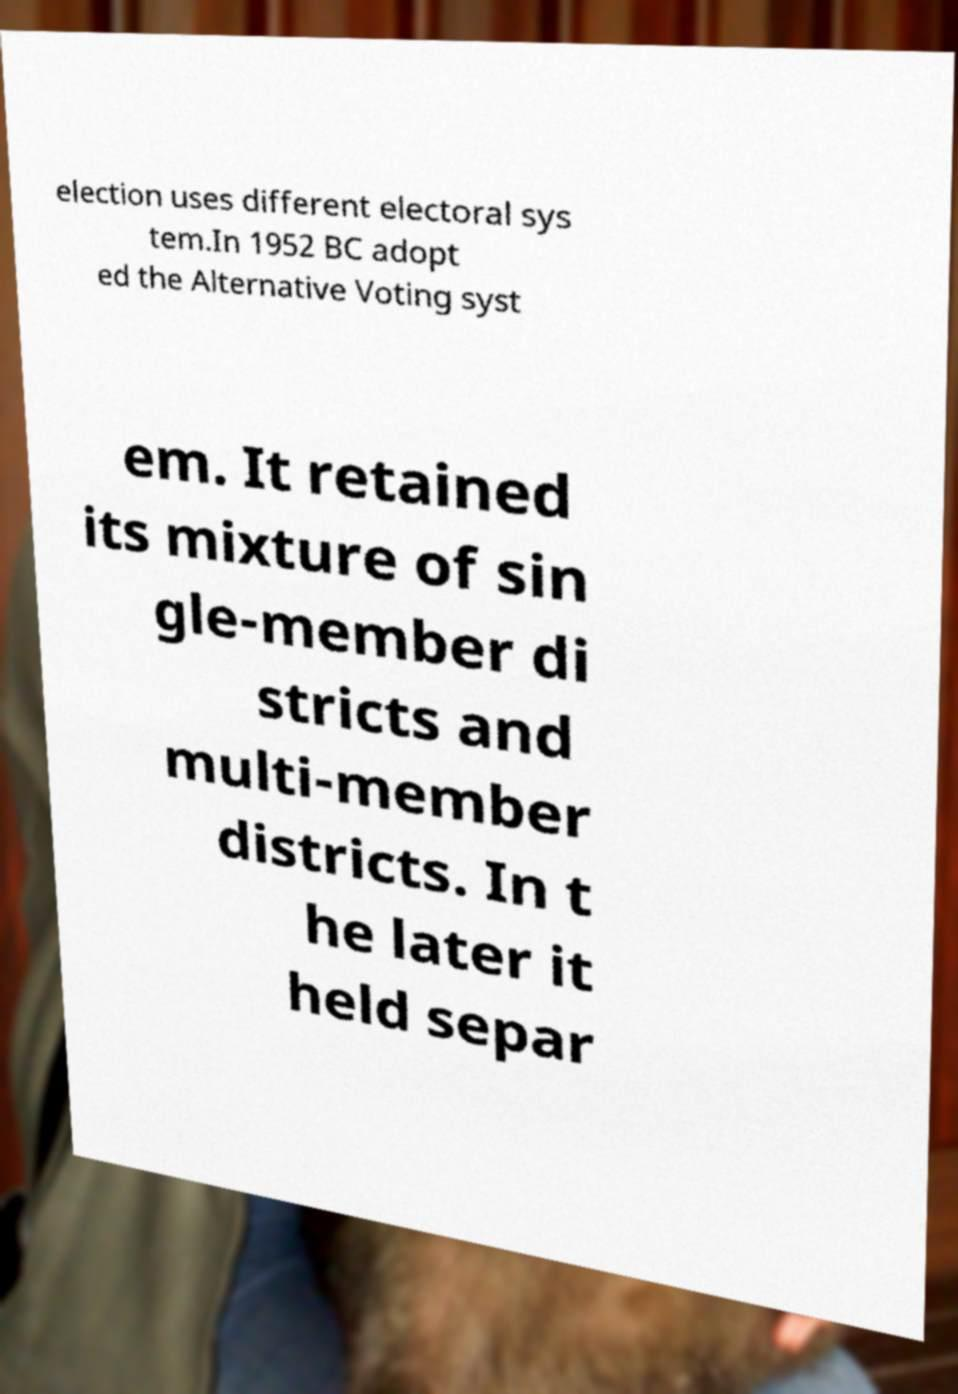Can you read and provide the text displayed in the image?This photo seems to have some interesting text. Can you extract and type it out for me? election uses different electoral sys tem.In 1952 BC adopt ed the Alternative Voting syst em. It retained its mixture of sin gle-member di stricts and multi-member districts. In t he later it held separ 